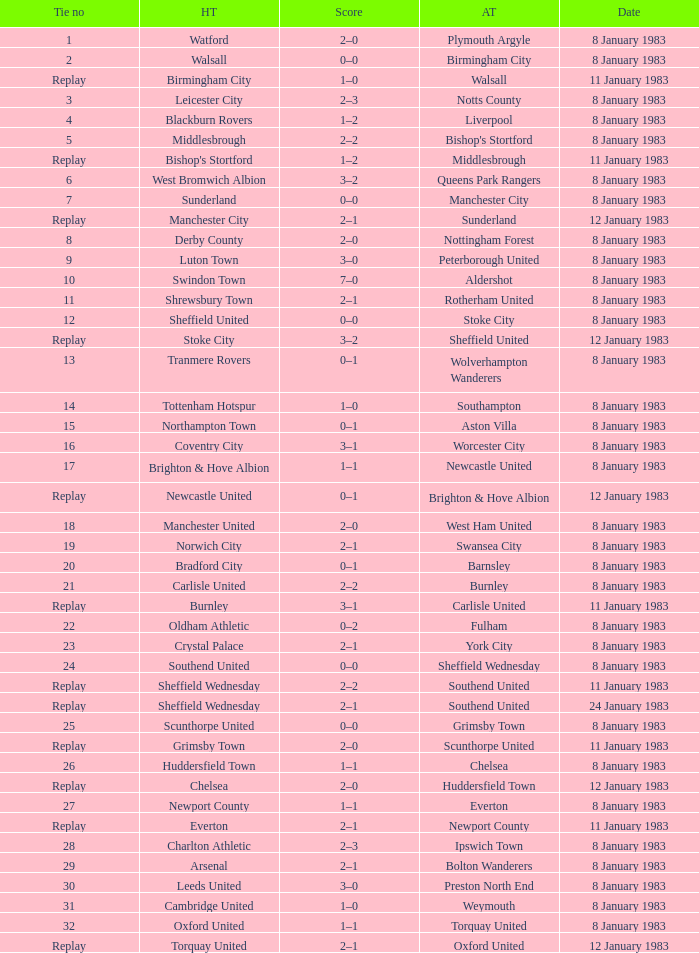For which tie was Scunthorpe United the away team? Replay. Give me the full table as a dictionary. {'header': ['Tie no', 'HT', 'Score', 'AT', 'Date'], 'rows': [['1', 'Watford', '2–0', 'Plymouth Argyle', '8 January 1983'], ['2', 'Walsall', '0–0', 'Birmingham City', '8 January 1983'], ['Replay', 'Birmingham City', '1–0', 'Walsall', '11 January 1983'], ['3', 'Leicester City', '2–3', 'Notts County', '8 January 1983'], ['4', 'Blackburn Rovers', '1–2', 'Liverpool', '8 January 1983'], ['5', 'Middlesbrough', '2–2', "Bishop's Stortford", '8 January 1983'], ['Replay', "Bishop's Stortford", '1–2', 'Middlesbrough', '11 January 1983'], ['6', 'West Bromwich Albion', '3–2', 'Queens Park Rangers', '8 January 1983'], ['7', 'Sunderland', '0–0', 'Manchester City', '8 January 1983'], ['Replay', 'Manchester City', '2–1', 'Sunderland', '12 January 1983'], ['8', 'Derby County', '2–0', 'Nottingham Forest', '8 January 1983'], ['9', 'Luton Town', '3–0', 'Peterborough United', '8 January 1983'], ['10', 'Swindon Town', '7–0', 'Aldershot', '8 January 1983'], ['11', 'Shrewsbury Town', '2–1', 'Rotherham United', '8 January 1983'], ['12', 'Sheffield United', '0–0', 'Stoke City', '8 January 1983'], ['Replay', 'Stoke City', '3–2', 'Sheffield United', '12 January 1983'], ['13', 'Tranmere Rovers', '0–1', 'Wolverhampton Wanderers', '8 January 1983'], ['14', 'Tottenham Hotspur', '1–0', 'Southampton', '8 January 1983'], ['15', 'Northampton Town', '0–1', 'Aston Villa', '8 January 1983'], ['16', 'Coventry City', '3–1', 'Worcester City', '8 January 1983'], ['17', 'Brighton & Hove Albion', '1–1', 'Newcastle United', '8 January 1983'], ['Replay', 'Newcastle United', '0–1', 'Brighton & Hove Albion', '12 January 1983'], ['18', 'Manchester United', '2–0', 'West Ham United', '8 January 1983'], ['19', 'Norwich City', '2–1', 'Swansea City', '8 January 1983'], ['20', 'Bradford City', '0–1', 'Barnsley', '8 January 1983'], ['21', 'Carlisle United', '2–2', 'Burnley', '8 January 1983'], ['Replay', 'Burnley', '3–1', 'Carlisle United', '11 January 1983'], ['22', 'Oldham Athletic', '0–2', 'Fulham', '8 January 1983'], ['23', 'Crystal Palace', '2–1', 'York City', '8 January 1983'], ['24', 'Southend United', '0–0', 'Sheffield Wednesday', '8 January 1983'], ['Replay', 'Sheffield Wednesday', '2–2', 'Southend United', '11 January 1983'], ['Replay', 'Sheffield Wednesday', '2–1', 'Southend United', '24 January 1983'], ['25', 'Scunthorpe United', '0–0', 'Grimsby Town', '8 January 1983'], ['Replay', 'Grimsby Town', '2–0', 'Scunthorpe United', '11 January 1983'], ['26', 'Huddersfield Town', '1–1', 'Chelsea', '8 January 1983'], ['Replay', 'Chelsea', '2–0', 'Huddersfield Town', '12 January 1983'], ['27', 'Newport County', '1–1', 'Everton', '8 January 1983'], ['Replay', 'Everton', '2–1', 'Newport County', '11 January 1983'], ['28', 'Charlton Athletic', '2–3', 'Ipswich Town', '8 January 1983'], ['29', 'Arsenal', '2–1', 'Bolton Wanderers', '8 January 1983'], ['30', 'Leeds United', '3–0', 'Preston North End', '8 January 1983'], ['31', 'Cambridge United', '1–0', 'Weymouth', '8 January 1983'], ['32', 'Oxford United', '1–1', 'Torquay United', '8 January 1983'], ['Replay', 'Torquay United', '2–1', 'Oxford United', '12 January 1983']]} 